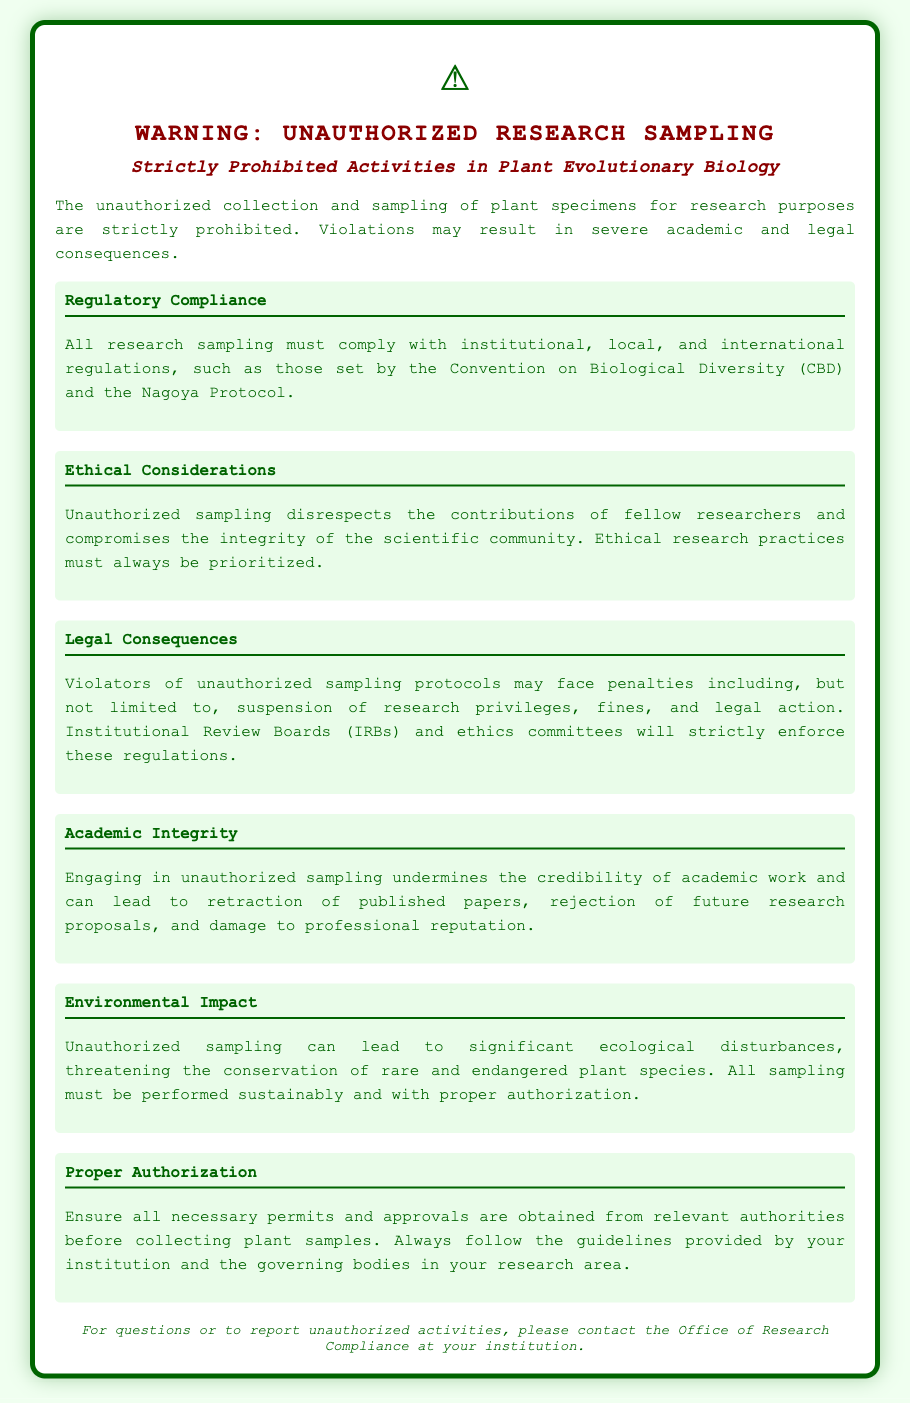what is the title of the document? The title of the document is prominently displayed in the header.
Answer: WARNING: UNAUTHORIZED RESEARCH SAMPLING what is strictly prohibited? The document states the specific activity that is not allowed in the context of research.
Answer: Unauthorized collection and sampling what may result from violations? The document mentions the possible consequences of violating the rules.
Answer: Severe academic and legal consequences which protocols must research sampling comply with? The document lists specific protocols that must be adhered to when conducting research sampling.
Answer: Convention on Biological Diversity and Nagoya Protocol what can unauthorized sampling undermine? The document emphasizes the negative impact of unauthorized sampling on a specific aspect of academic work.
Answer: Academic integrity who should be contacted for reporting unauthorized activities? At the end of the document, a department is mentioned for inquiries and reports.
Answer: Office of Research Compliance what environmental issue can unauthorized sampling cause? The document refers to a specific consequence of unauthorized sampling related to ecology.
Answer: Significant ecological disturbances what must be obtained before collecting plant samples? The document specifies what is required to collect samples legally.
Answer: Necessary permits and approvals what enforcement body will monitor sampling violations? The document mentions a specific committee that will ensure compliance with the rules.
Answer: Institutional Review Boards (IRBs) and ethics committees 